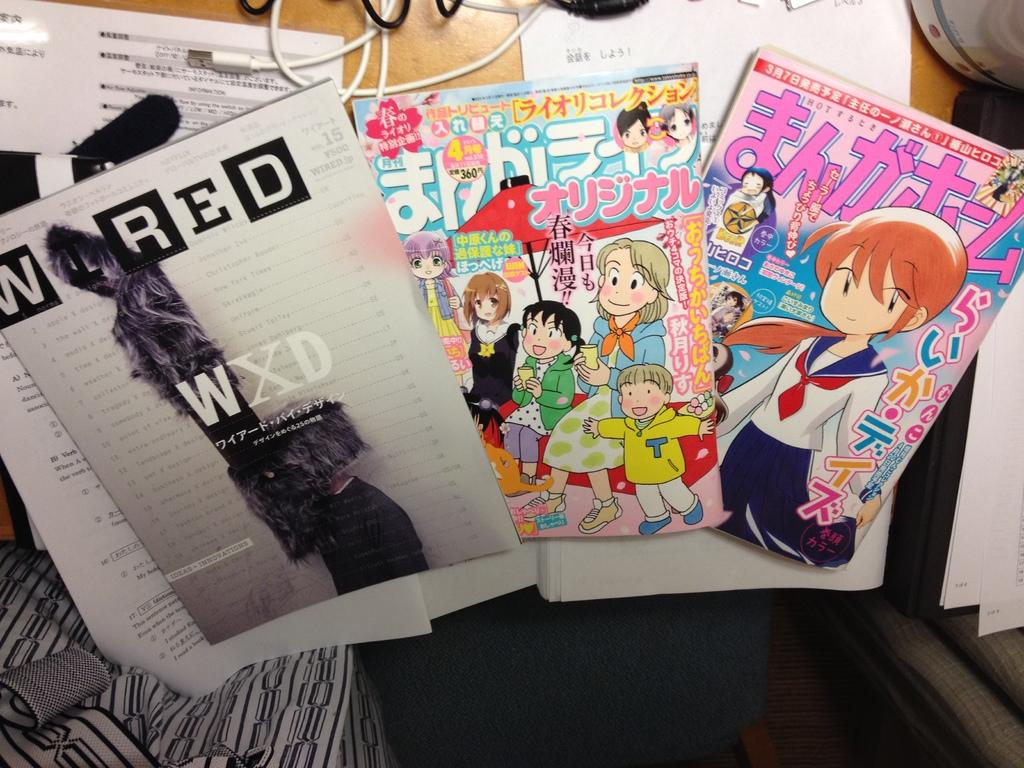What objects are on the table in the image? There are books and papers on the table. What is the color of the table? The table is cream-colored. Can you describe the wire in the image? There is a white-colored wire in the image. What can be said about the variety of books on the table? There are different colors of books on the table. Are there any fairies flying around the table in the image? No, there are no fairies present in the image. Can you tell me how many boys are sitting at the table in the image? There is no mention of boys or anyone sitting at the table in the image. 